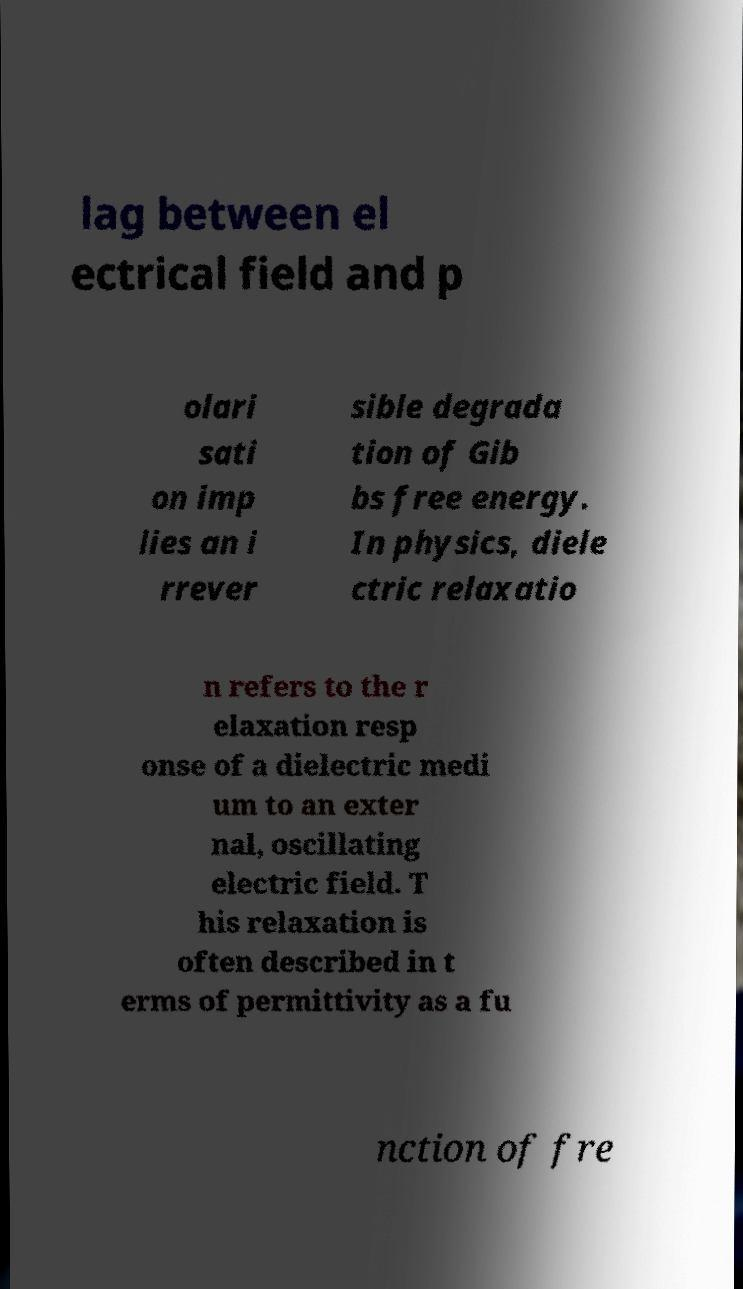Could you extract and type out the text from this image? lag between el ectrical field and p olari sati on imp lies an i rrever sible degrada tion of Gib bs free energy. In physics, diele ctric relaxatio n refers to the r elaxation resp onse of a dielectric medi um to an exter nal, oscillating electric field. T his relaxation is often described in t erms of permittivity as a fu nction of fre 